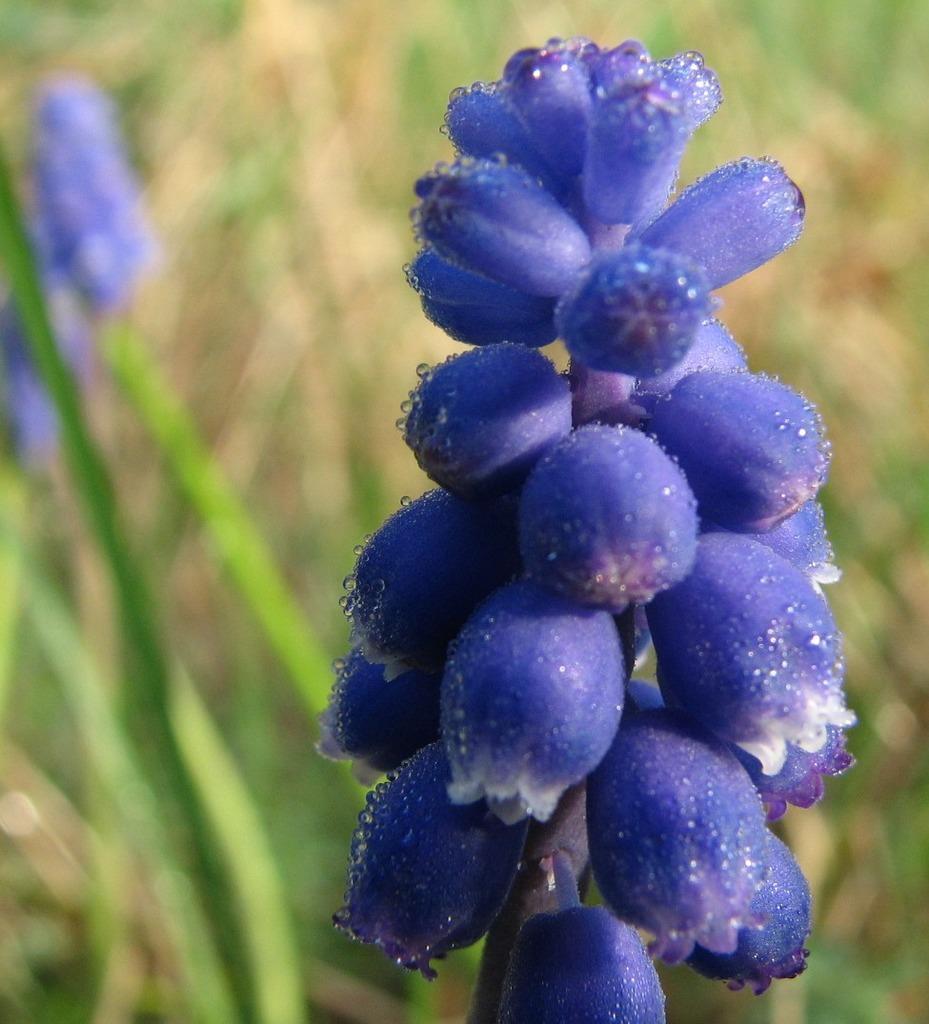Please provide a concise description of this image. in this picture there is a flower plant on the left side of the image, which is purple in color and there are other plants in the background area of the image. 